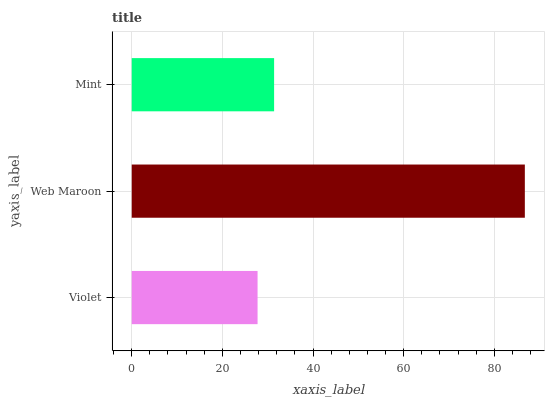Is Violet the minimum?
Answer yes or no. Yes. Is Web Maroon the maximum?
Answer yes or no. Yes. Is Mint the minimum?
Answer yes or no. No. Is Mint the maximum?
Answer yes or no. No. Is Web Maroon greater than Mint?
Answer yes or no. Yes. Is Mint less than Web Maroon?
Answer yes or no. Yes. Is Mint greater than Web Maroon?
Answer yes or no. No. Is Web Maroon less than Mint?
Answer yes or no. No. Is Mint the high median?
Answer yes or no. Yes. Is Mint the low median?
Answer yes or no. Yes. Is Web Maroon the high median?
Answer yes or no. No. Is Web Maroon the low median?
Answer yes or no. No. 